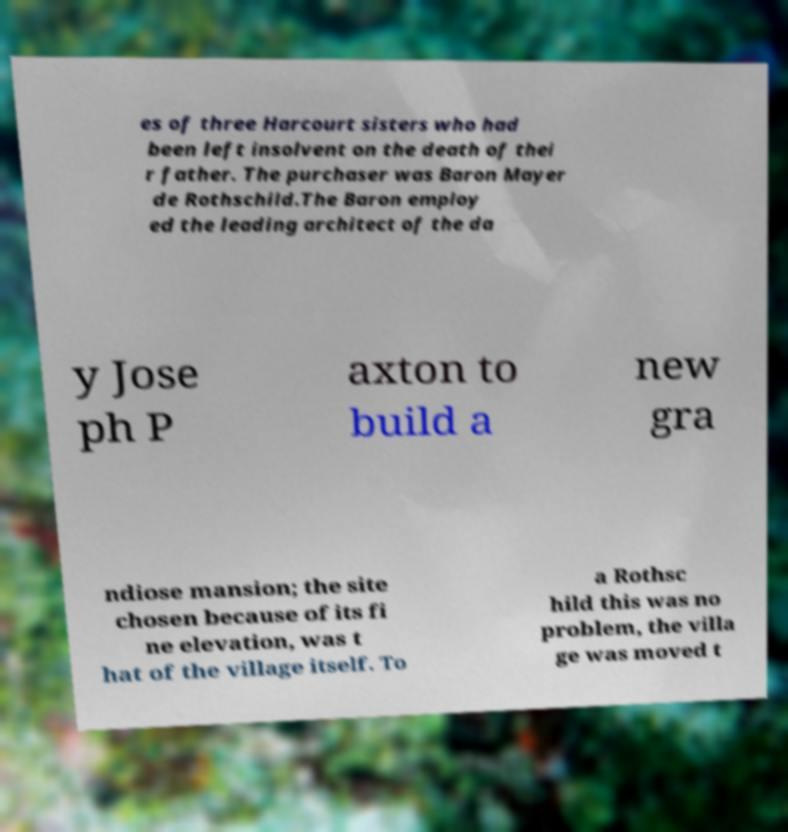Could you extract and type out the text from this image? es of three Harcourt sisters who had been left insolvent on the death of thei r father. The purchaser was Baron Mayer de Rothschild.The Baron employ ed the leading architect of the da y Jose ph P axton to build a new gra ndiose mansion; the site chosen because of its fi ne elevation, was t hat of the village itself. To a Rothsc hild this was no problem, the villa ge was moved t 